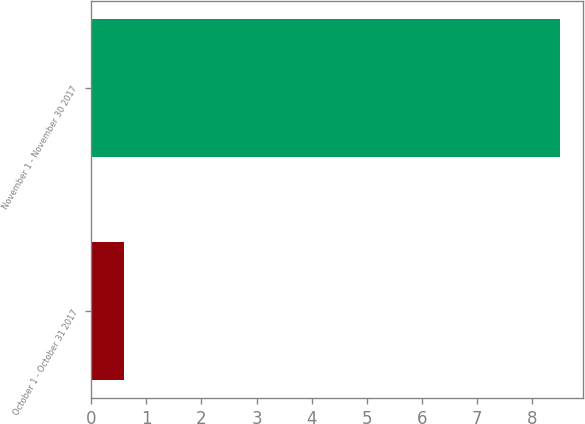Convert chart to OTSL. <chart><loc_0><loc_0><loc_500><loc_500><bar_chart><fcel>October 1 - October 31 2017<fcel>November 1 - November 30 2017<nl><fcel>0.6<fcel>8.5<nl></chart> 